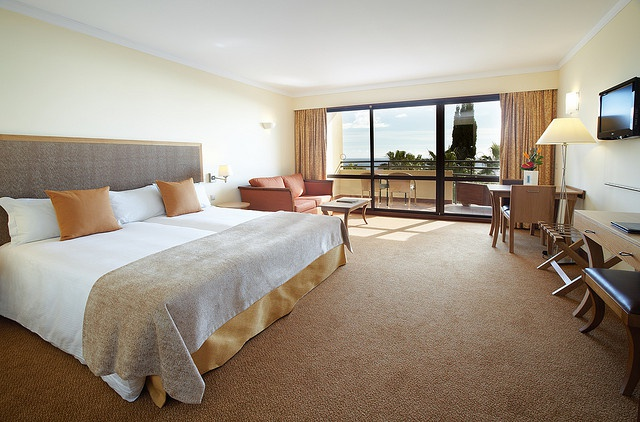Describe the objects in this image and their specific colors. I can see bed in darkgray, lightgray, and gray tones, chair in darkgray, black, maroon, and gray tones, bench in darkgray, black, maroon, and gray tones, couch in darkgray, brown, tan, and maroon tones, and chair in darkgray, brown, maroon, black, and gray tones in this image. 